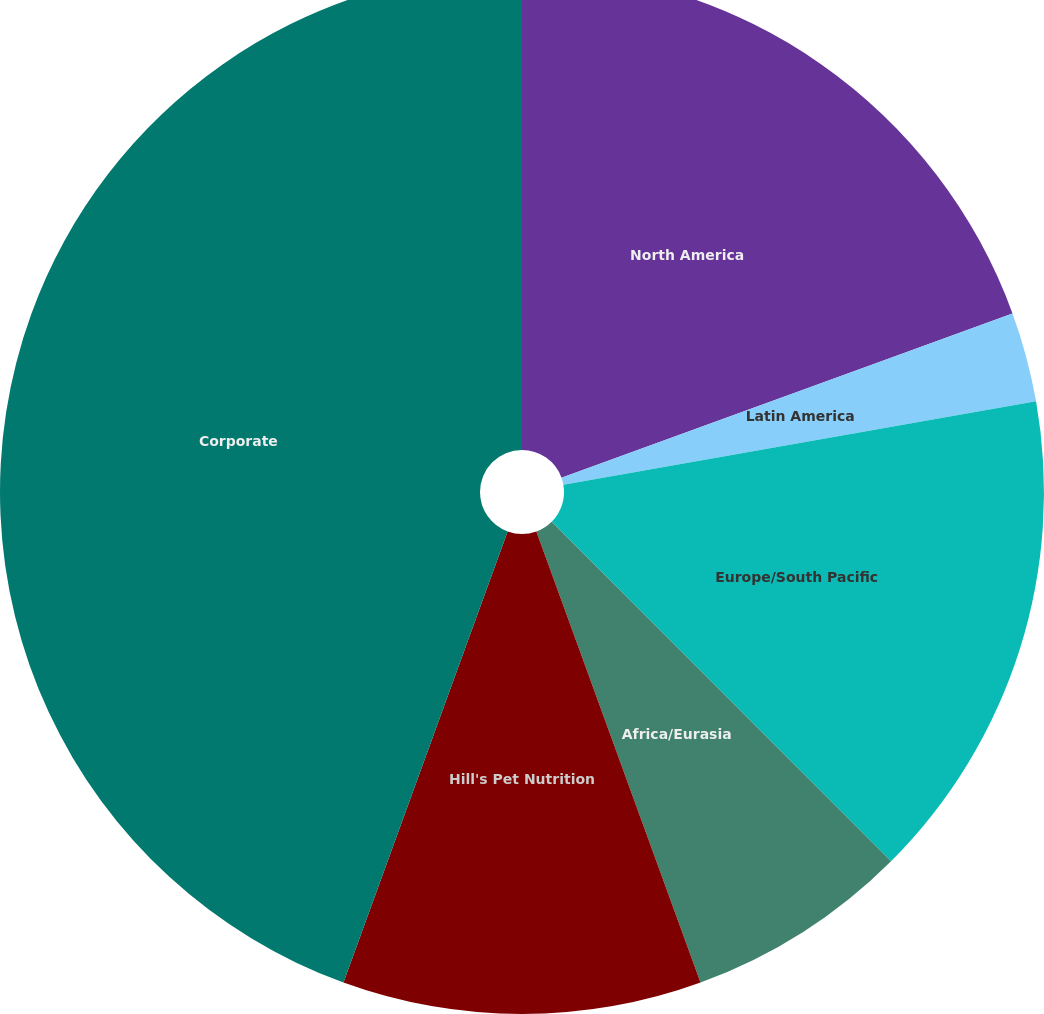<chart> <loc_0><loc_0><loc_500><loc_500><pie_chart><fcel>North America<fcel>Latin America<fcel>Europe/South Pacific<fcel>Africa/Eurasia<fcel>Hill's Pet Nutrition<fcel>Corporate<nl><fcel>19.44%<fcel>2.78%<fcel>15.28%<fcel>6.94%<fcel>11.11%<fcel>44.44%<nl></chart> 